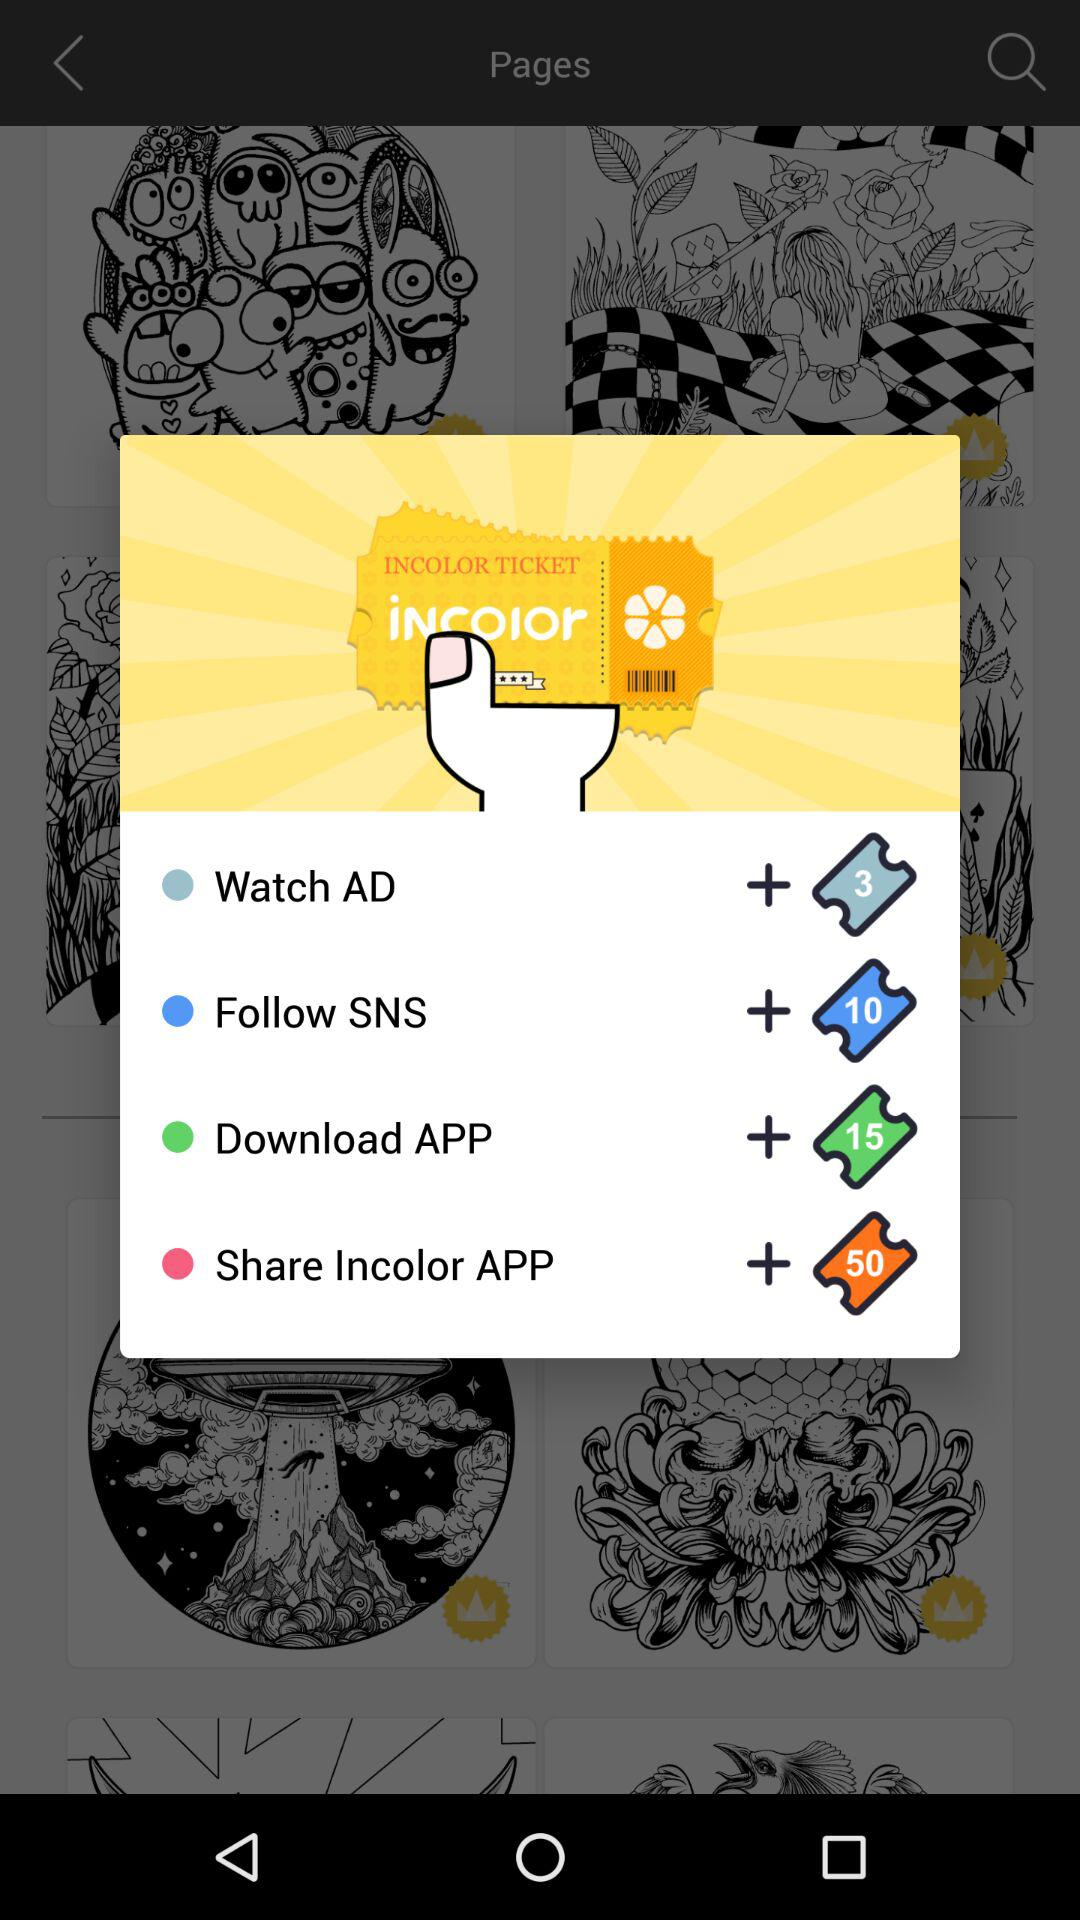What is the price for download the application?
When the provided information is insufficient, respond with <no answer>. <no answer> 